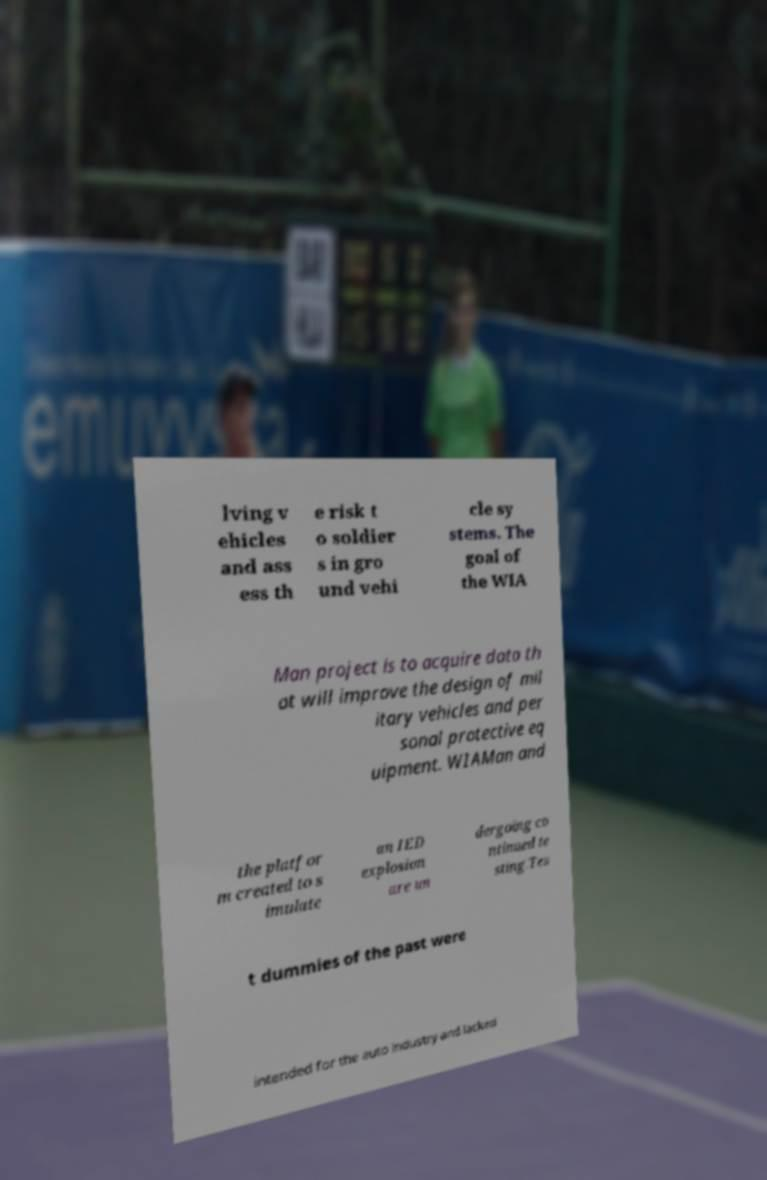Please identify and transcribe the text found in this image. lving v ehicles and ass ess th e risk t o soldier s in gro und vehi cle sy stems. The goal of the WIA Man project is to acquire data th at will improve the design of mil itary vehicles and per sonal protective eq uipment. WIAMan and the platfor m created to s imulate an IED explosion are un dergoing co ntinued te sting.Tes t dummies of the past were intended for the auto industry and lacked 